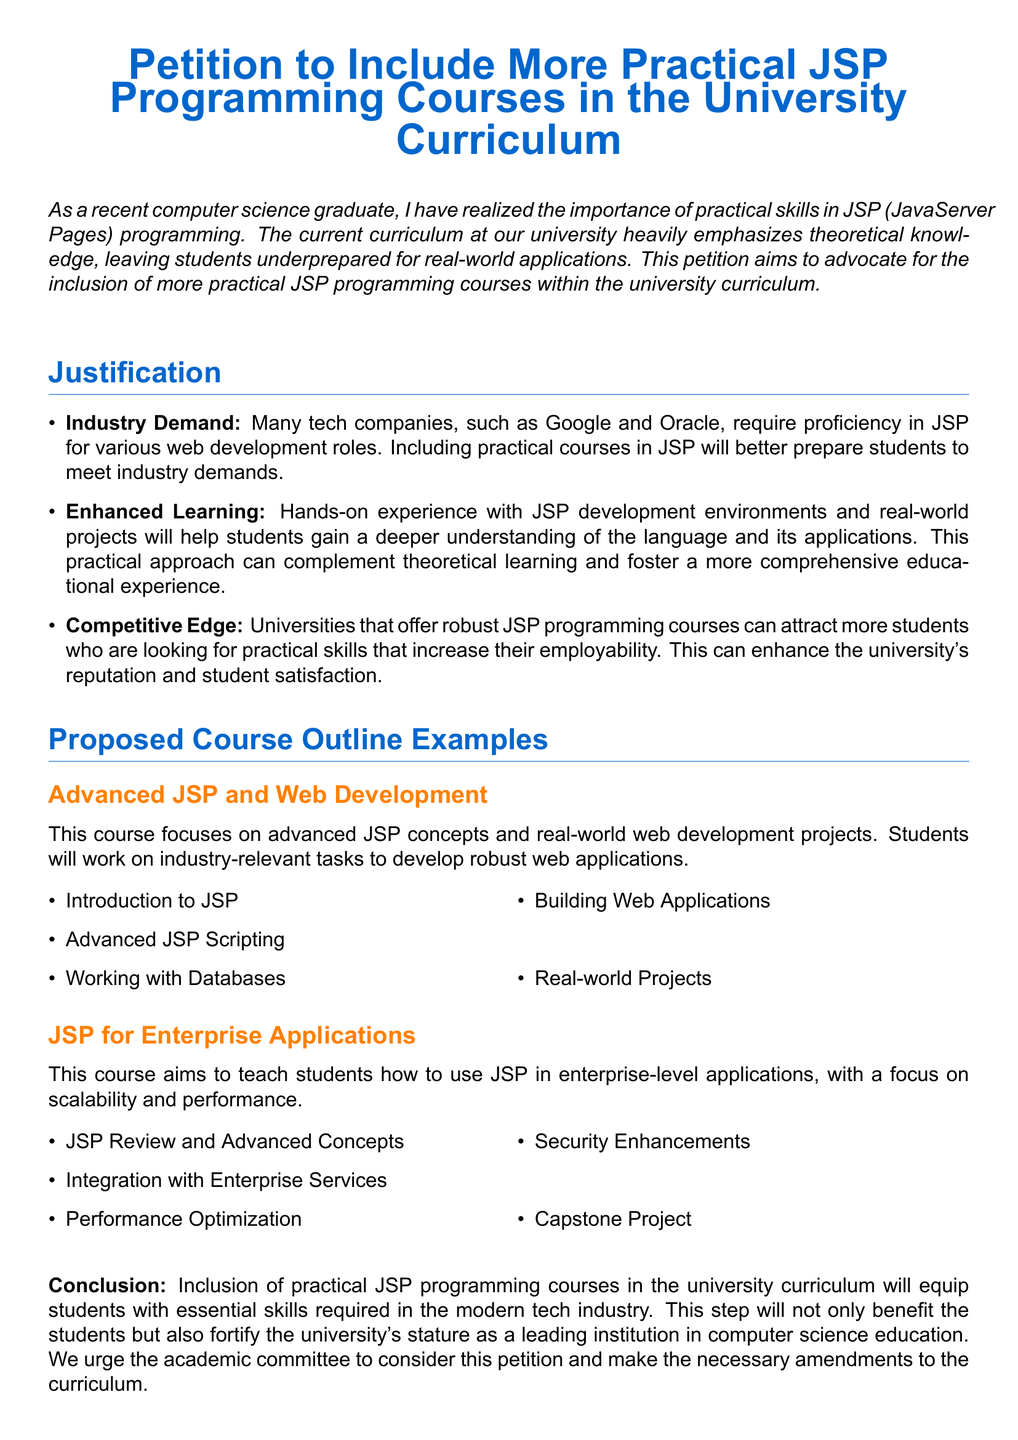What is the main purpose of the petition? The petition aims to advocate for the inclusion of more practical JSP programming courses within the university curriculum.
Answer: Advocate for practical JSP programming courses What companies require proficiency in JSP? The document mentions that companies such as Google and Oracle require proficiency in JSP for various web development roles.
Answer: Google and Oracle What is the first item listed in the course outline for "Advanced JSP and Web Development"? The first item in the course outline is "Introduction to JSP."
Answer: Introduction to JSP How many proposed course outline examples are provided? The document provides two proposed course outline examples: "Advanced JSP and Web Development" and "JSP for Enterprise Applications."
Answer: Two What is the focus of the course "JSP for Enterprise Applications"? The focus of this course is on teaching how to use JSP in enterprise-level applications, with an emphasis on scalability and performance.
Answer: Scalability and performance What is one benefit of including practical JSP programming courses mentioned in the document? One benefit mentioned is that it will equip students with essential skills required in the modern tech industry.
Answer: Essential skills What does the petition urge the academic committee to do? The petition urges the academic committee to consider this petition and make the necessary amendments to the curriculum.
Answer: Make necessary amendments What type of document is this? The document is a petition advocating for curriculum changes in the university.
Answer: Petition What color is used for the section titles in the document? The section titles are colored in a main color defined as RGB (0,102,204).
Answer: RGB (0,102,204) 